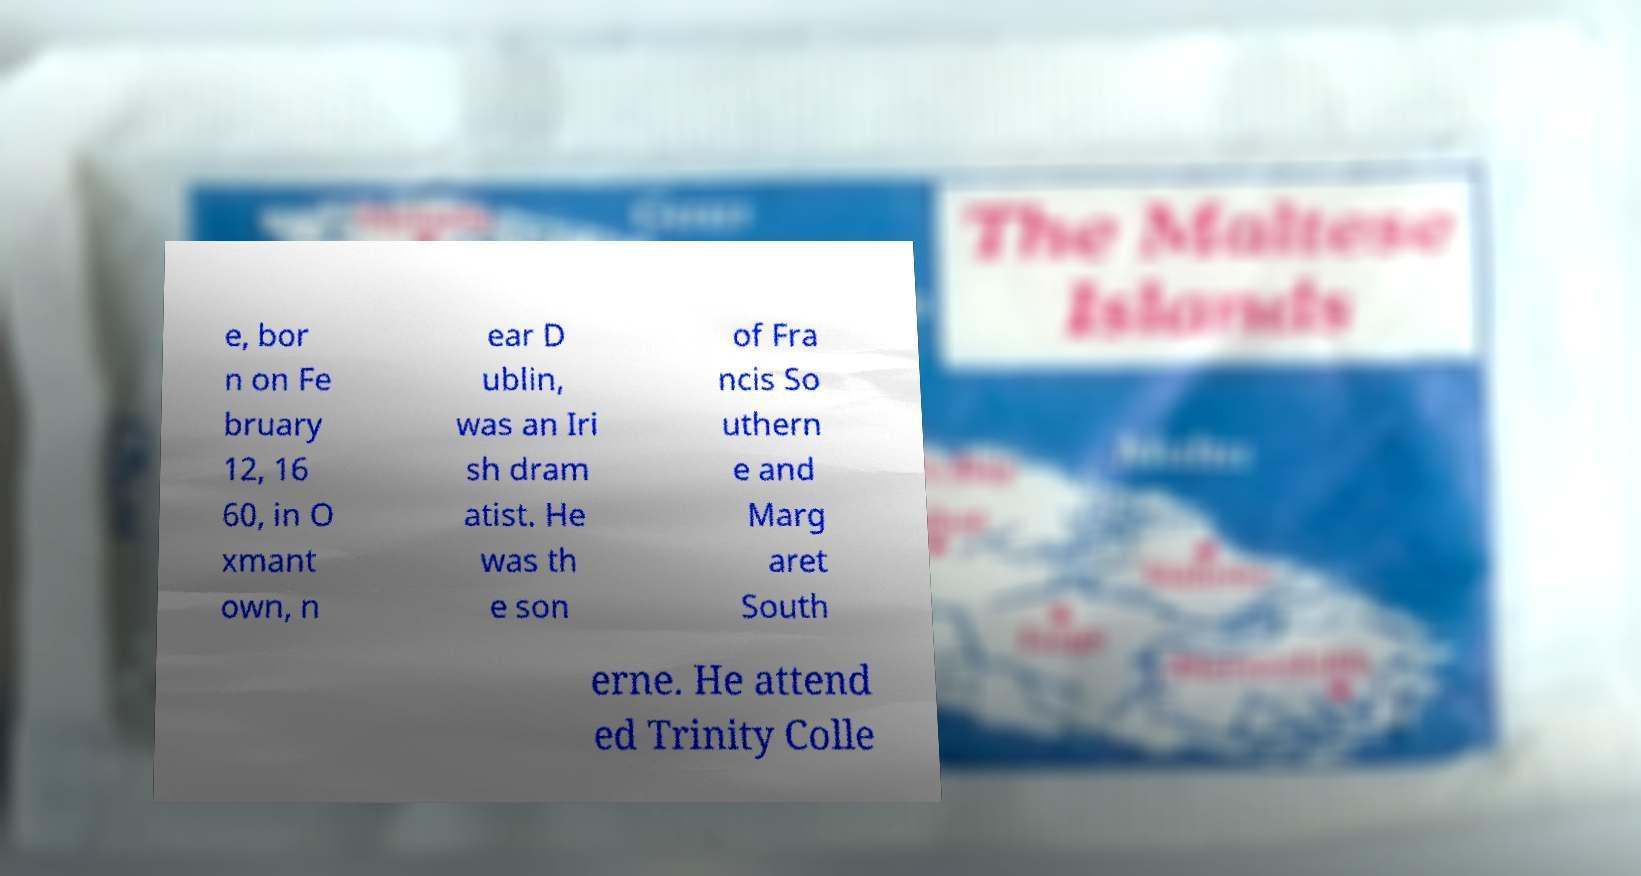Could you assist in decoding the text presented in this image and type it out clearly? e, bor n on Fe bruary 12, 16 60, in O xmant own, n ear D ublin, was an Iri sh dram atist. He was th e son of Fra ncis So uthern e and Marg aret South erne. He attend ed Trinity Colle 